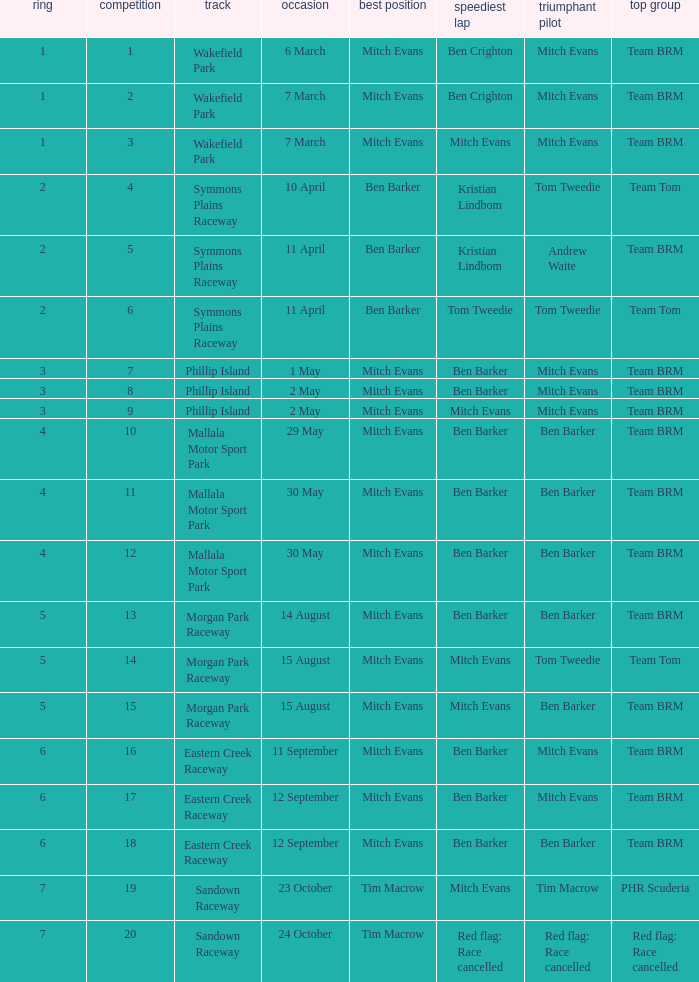In how many rounds was Race 17? 1.0. 